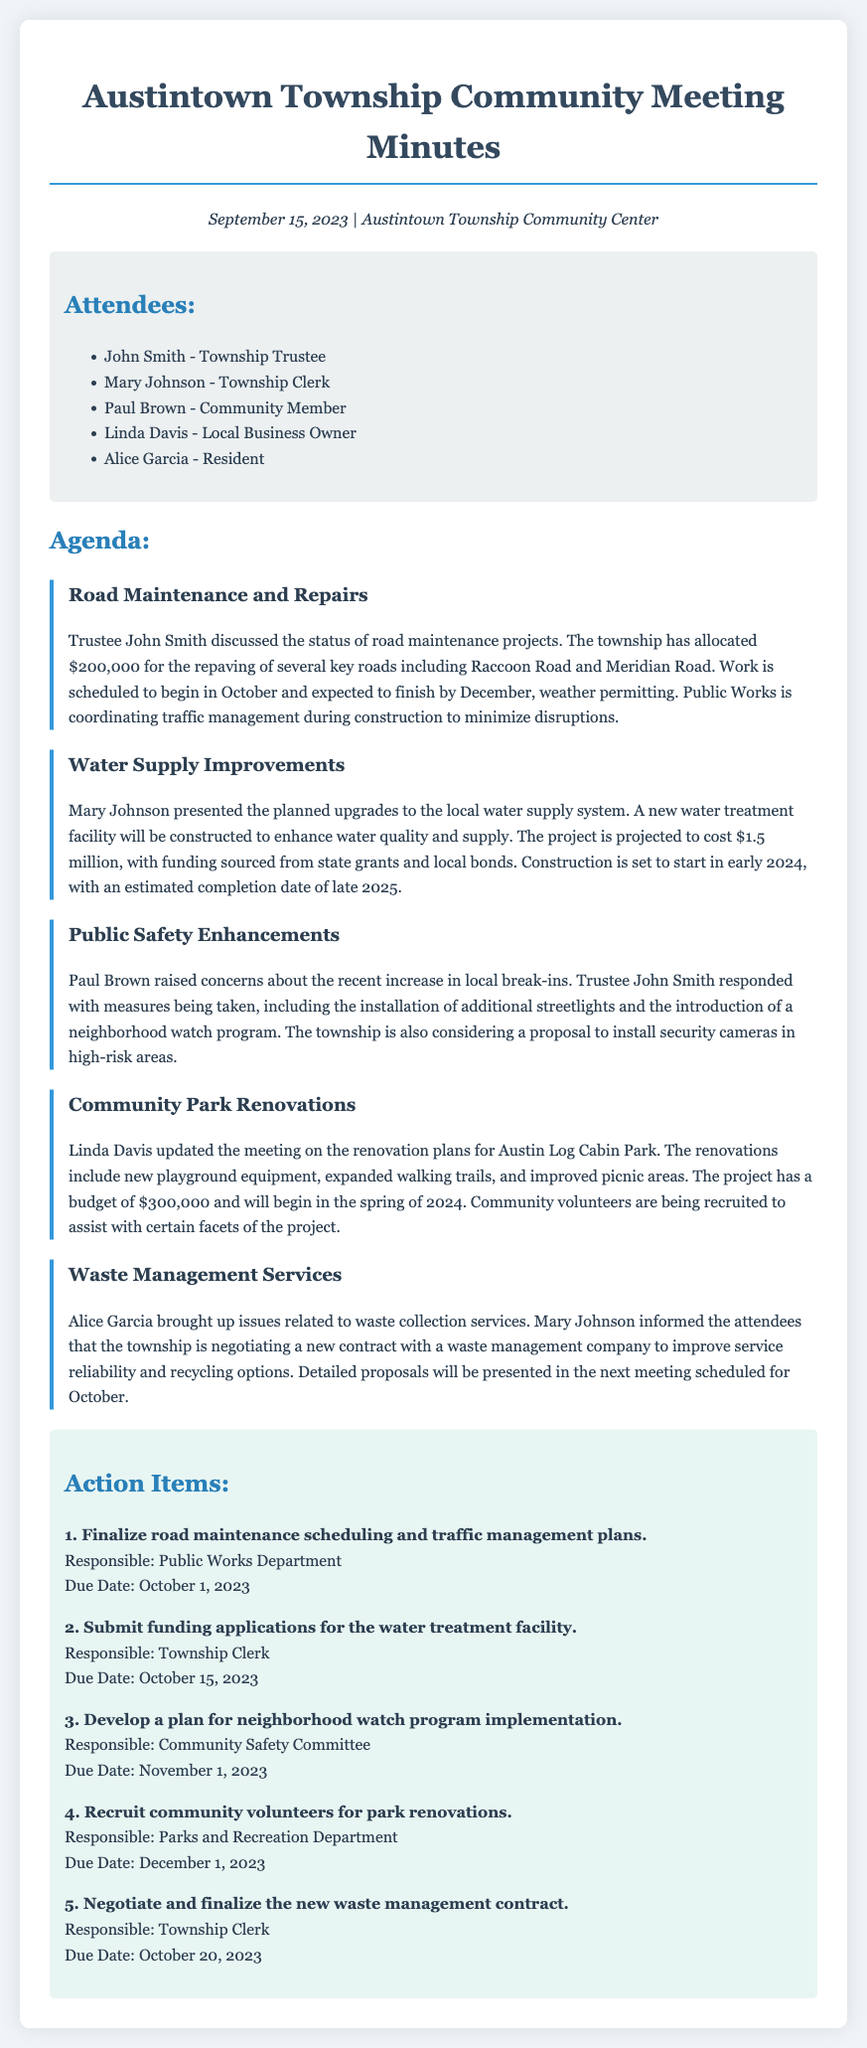What is the date of the meeting? The date of the meeting is specified in the document header.
Answer: September 15, 2023 How much is allocated for road maintenance? The document states the amount allocated for road maintenance projects.
Answer: $200,000 Who presented the planned upgrades to the water supply system? The document lists Mary Johnson as the presenter of the water supply improvements.
Answer: Mary Johnson What is the projected cost for the new water treatment facility? The document mentions the projected cost for this project.
Answer: $1.5 million When is the construction for the new water treatment facility set to start? The document indicates the timeline for the water treatment facility's construction.
Answer: Early 2024 What are the proposed enhancements for public safety? The document outlines the measures taken to enhance public safety mentioned in the meeting.
Answer: Installation of additional streetlights and neighborhood watch program How much is the budget for the park renovations? The document specifies the budget allocated for park renovations.
Answer: $300,000 What is the due date for finalizing the road maintenance scheduling? The document lists specific action items and their due dates.
Answer: October 1, 2023 Who is responsible for negotiating the new waste management contract? The document names the responsible party for this action item.
Answer: Township Clerk 